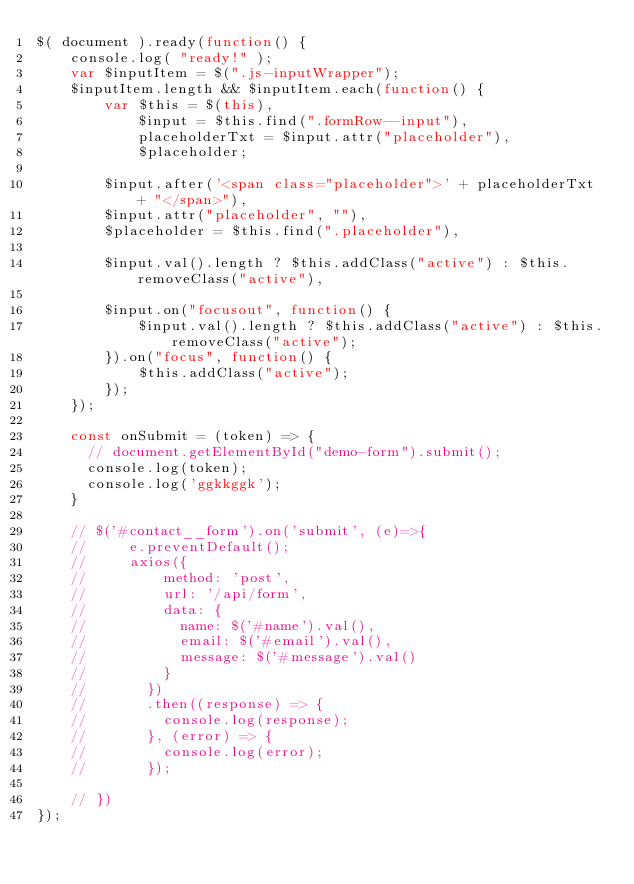<code> <loc_0><loc_0><loc_500><loc_500><_JavaScript_>$( document ).ready(function() {
    console.log( "ready!" );
    var $inputItem = $(".js-inputWrapper");
    $inputItem.length && $inputItem.each(function() {
        var $this = $(this),
            $input = $this.find(".formRow--input"),
            placeholderTxt = $input.attr("placeholder"),
            $placeholder;
        
        $input.after('<span class="placeholder">' + placeholderTxt + "</span>"),
        $input.attr("placeholder", ""),
        $placeholder = $this.find(".placeholder"),
        
        $input.val().length ? $this.addClass("active") : $this.removeClass("active"),
            
        $input.on("focusout", function() {
            $input.val().length ? $this.addClass("active") : $this.removeClass("active");
        }).on("focus", function() {
            $this.addClass("active");
        });
    });

    const onSubmit = (token) => {
      // document.getElementById("demo-form").submit();
      console.log(token);
      console.log('ggkkggk');
    }

    // $('#contact__form').on('submit', (e)=>{
    //     e.preventDefault();
    //     axios({
    //         method: 'post',
    //         url: '/api/form',
    //         data: {
    //           name: $('#name').val(),
    //           email: $('#email').val(),
    //           message: $('#message').val()
    //         }
    //       })
    //       .then((response) => {
    //         console.log(response);
    //       }, (error) => {
    //         console.log(error);
    //       });
          
    // })
});</code> 